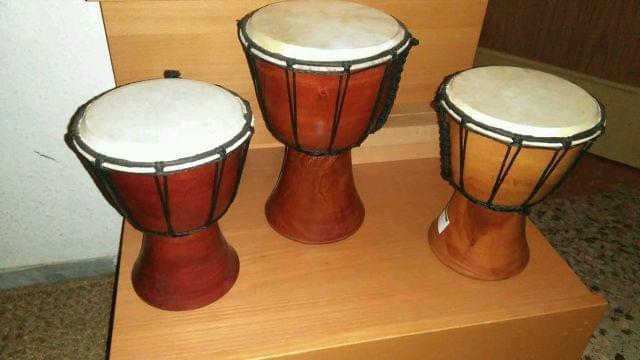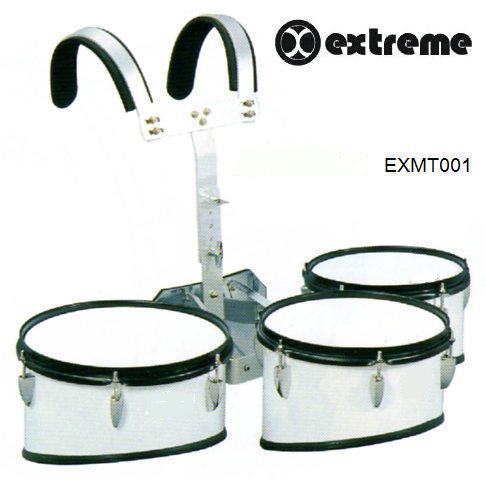The first image is the image on the left, the second image is the image on the right. Examine the images to the left and right. Is the description "The left image shows three pedestal-shaped drums with wood-grain exteriors, and the right image shows at least three white drums with black rims." accurate? Answer yes or no. Yes. The first image is the image on the left, the second image is the image on the right. For the images shown, is this caption "There are three bongo drums." true? Answer yes or no. Yes. 